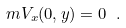<formula> <loc_0><loc_0><loc_500><loc_500>\ m V _ { x } ( 0 , y ) = 0 \ .</formula> 